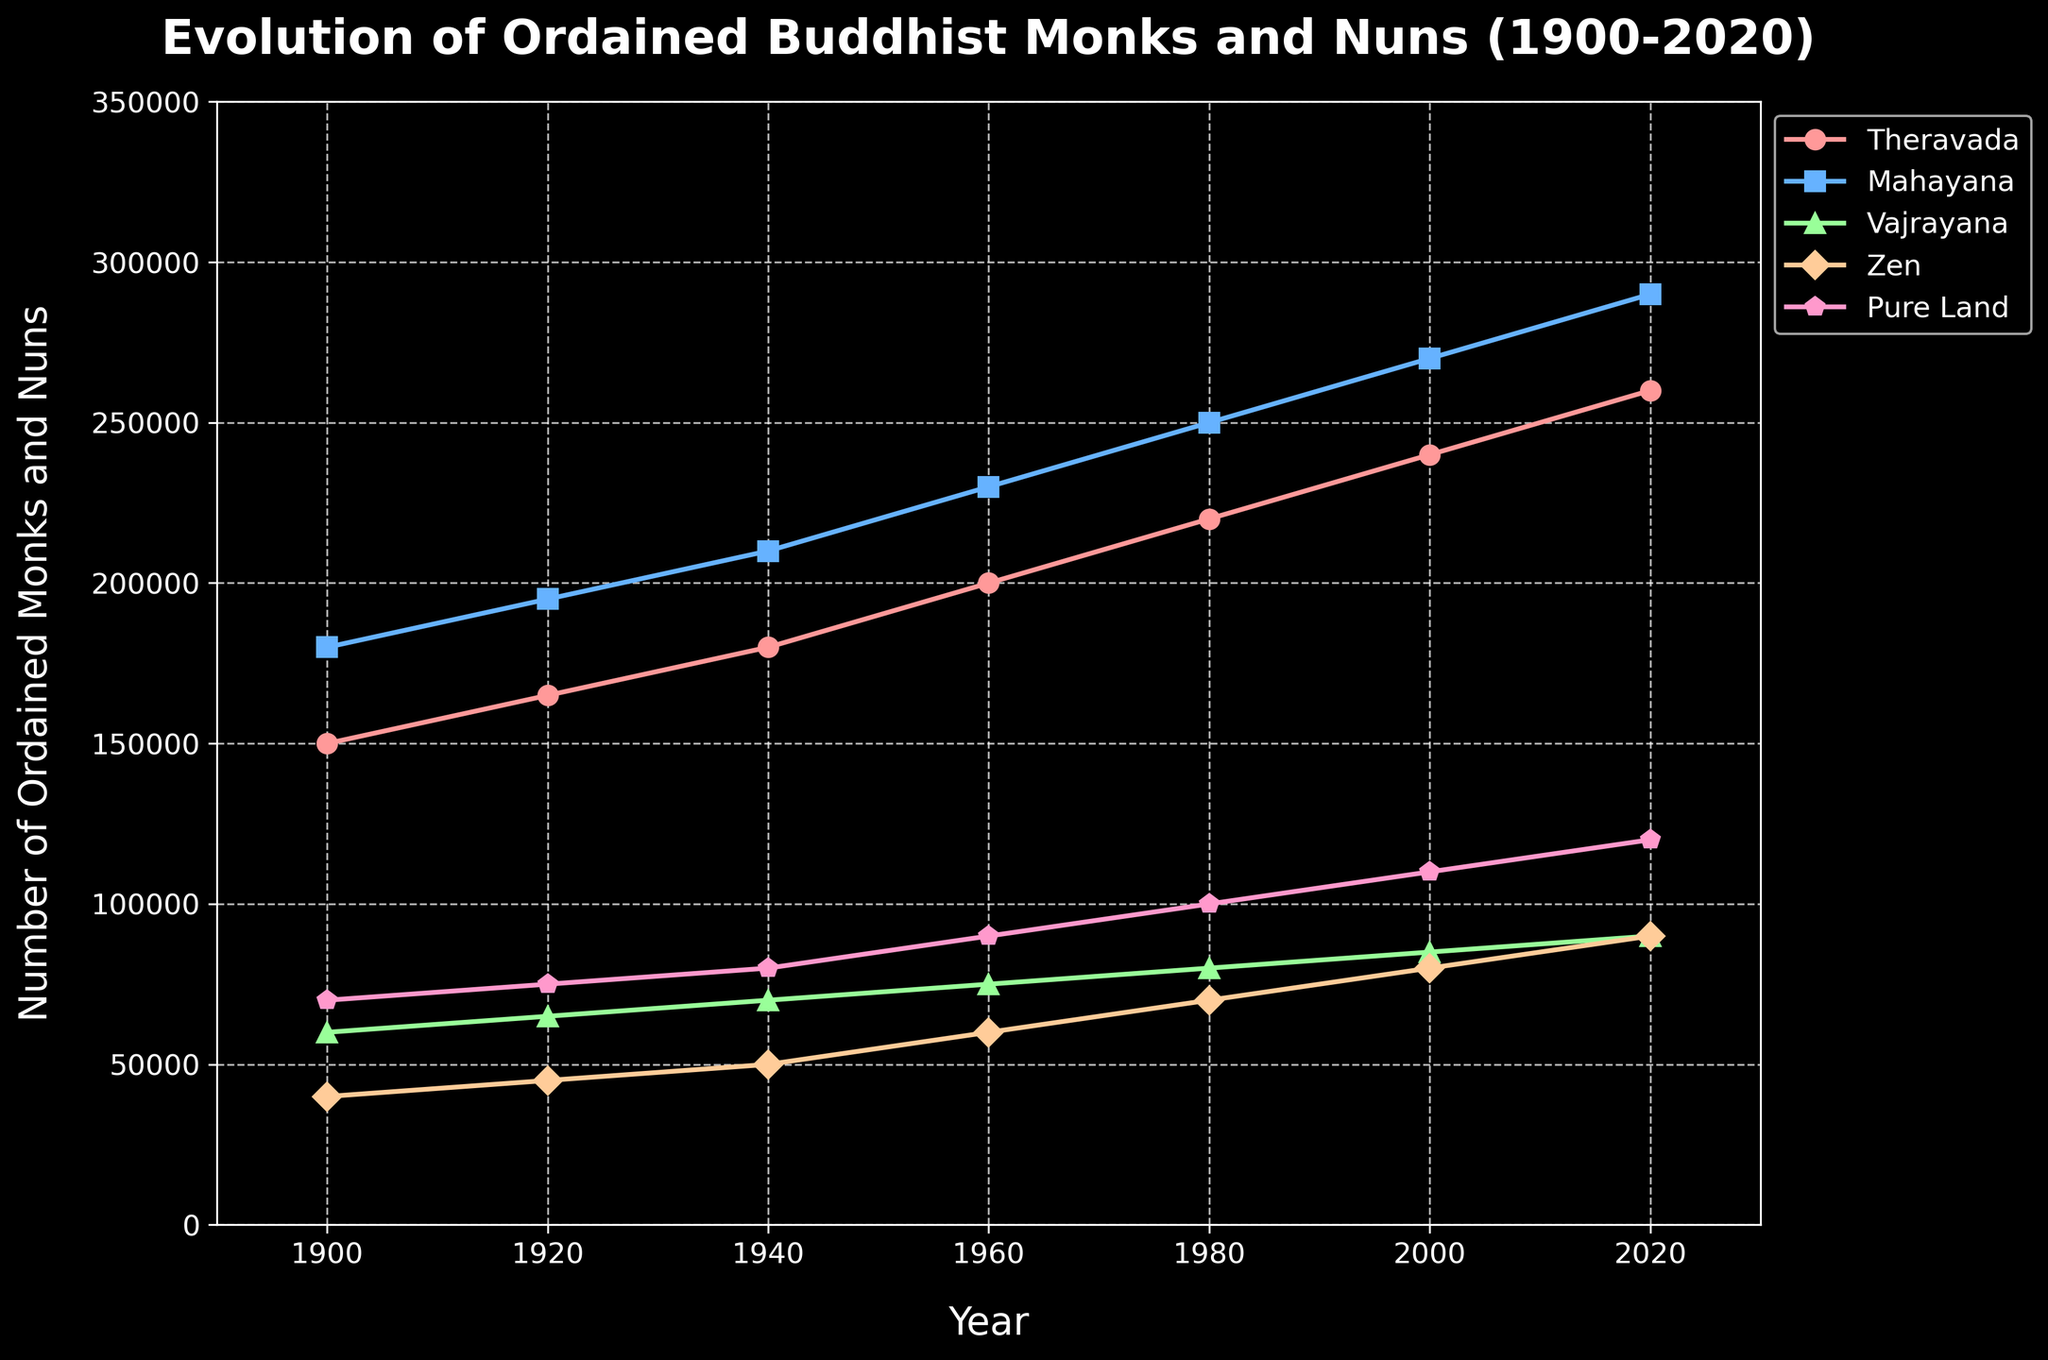Which tradition had the highest number of ordained monks and nuns in 1920? By observing the figure, the Mahayana tradition had the highest number in 1920.
Answer: Mahayana Which tradition showed the greatest increase in the number of ordained monks and nuns between 1900 and 2020? By calculating the difference for each tradition: Theravada increased by 110,000, Mahayana by 110,000, Vajrayana by 30,000, Zen by 50,000, Pure Land by 50,000.
Answer: Theravada and Mahayana How did the number of Zen ordained monks and nuns change from 1940 to 1980? The figure shows an increase from 50,000 in 1940 to 70,000 in 1980, meaning a change of +20,000.
Answer: +20,000 Which two traditions had approximately equal numbers of ordained monks and nuns in 2000? By looking at 2000, both Zen and Pure Land had near numbers of 80,000 ordained monks and nuns.
Answer: Zen and Pure Land How many more ordained monks and nuns did the Pure Land tradition have in 2020 compared to 1900? Pure Land had 120,000 in 2020 and 70,000 in 1900, giving an increase of 50,000.
Answer: +50,000 What's the average number of ordained monks and nuns in the Theravada tradition between 1900 and 2020? By summing the values for Theravada (150,000 + 165,000 + 180,000 + 200,000 + 220,000 + 240,000 + 260,000) we get 1,415,000, divided by 7 (the number of years), the average is 202,142.86.
Answer: 202,142.86 During which period did the Vajrayana tradition see the smallest increase in the number of ordained monks and nuns? By analyzing the years between the intervals: 1900-1920 (+5,000), 1920-1940 (+5,000), 1940-1960 (+5,000), 1960-1980 (+5,000), 1980-2000 (+5,000), 2000-2020 (+5,000), all periods had an equal increase.
Answer: 1920-2020 In what year did the number of Mahayana ordained monks and nuns first reach 250,000? The figure shows that in 1980, Mahayana reached 250,000 ordained monks and nuns for the first time.
Answer: 1980 How does the trend for the number of ordained monks and nuns in the Pure Land tradition compare to Zen from 1960 to 2020? From 1960 to 2020, Pure Land increased from 90,000 to 120,000 (+30,000), while Zen increased from 60,000 to 90,000 (+30,000). Both traditions increased by 30,000, indicating similar trends.
Answer: Similar trends If we sum the number of ordained monks and nuns for all traditions in 2020, what is the total? By summing the 2020 values for all traditions: (260,000 + 290,000 + 90,000 + 90,000 + 120,000) we get 850,000.
Answer: 850,000 